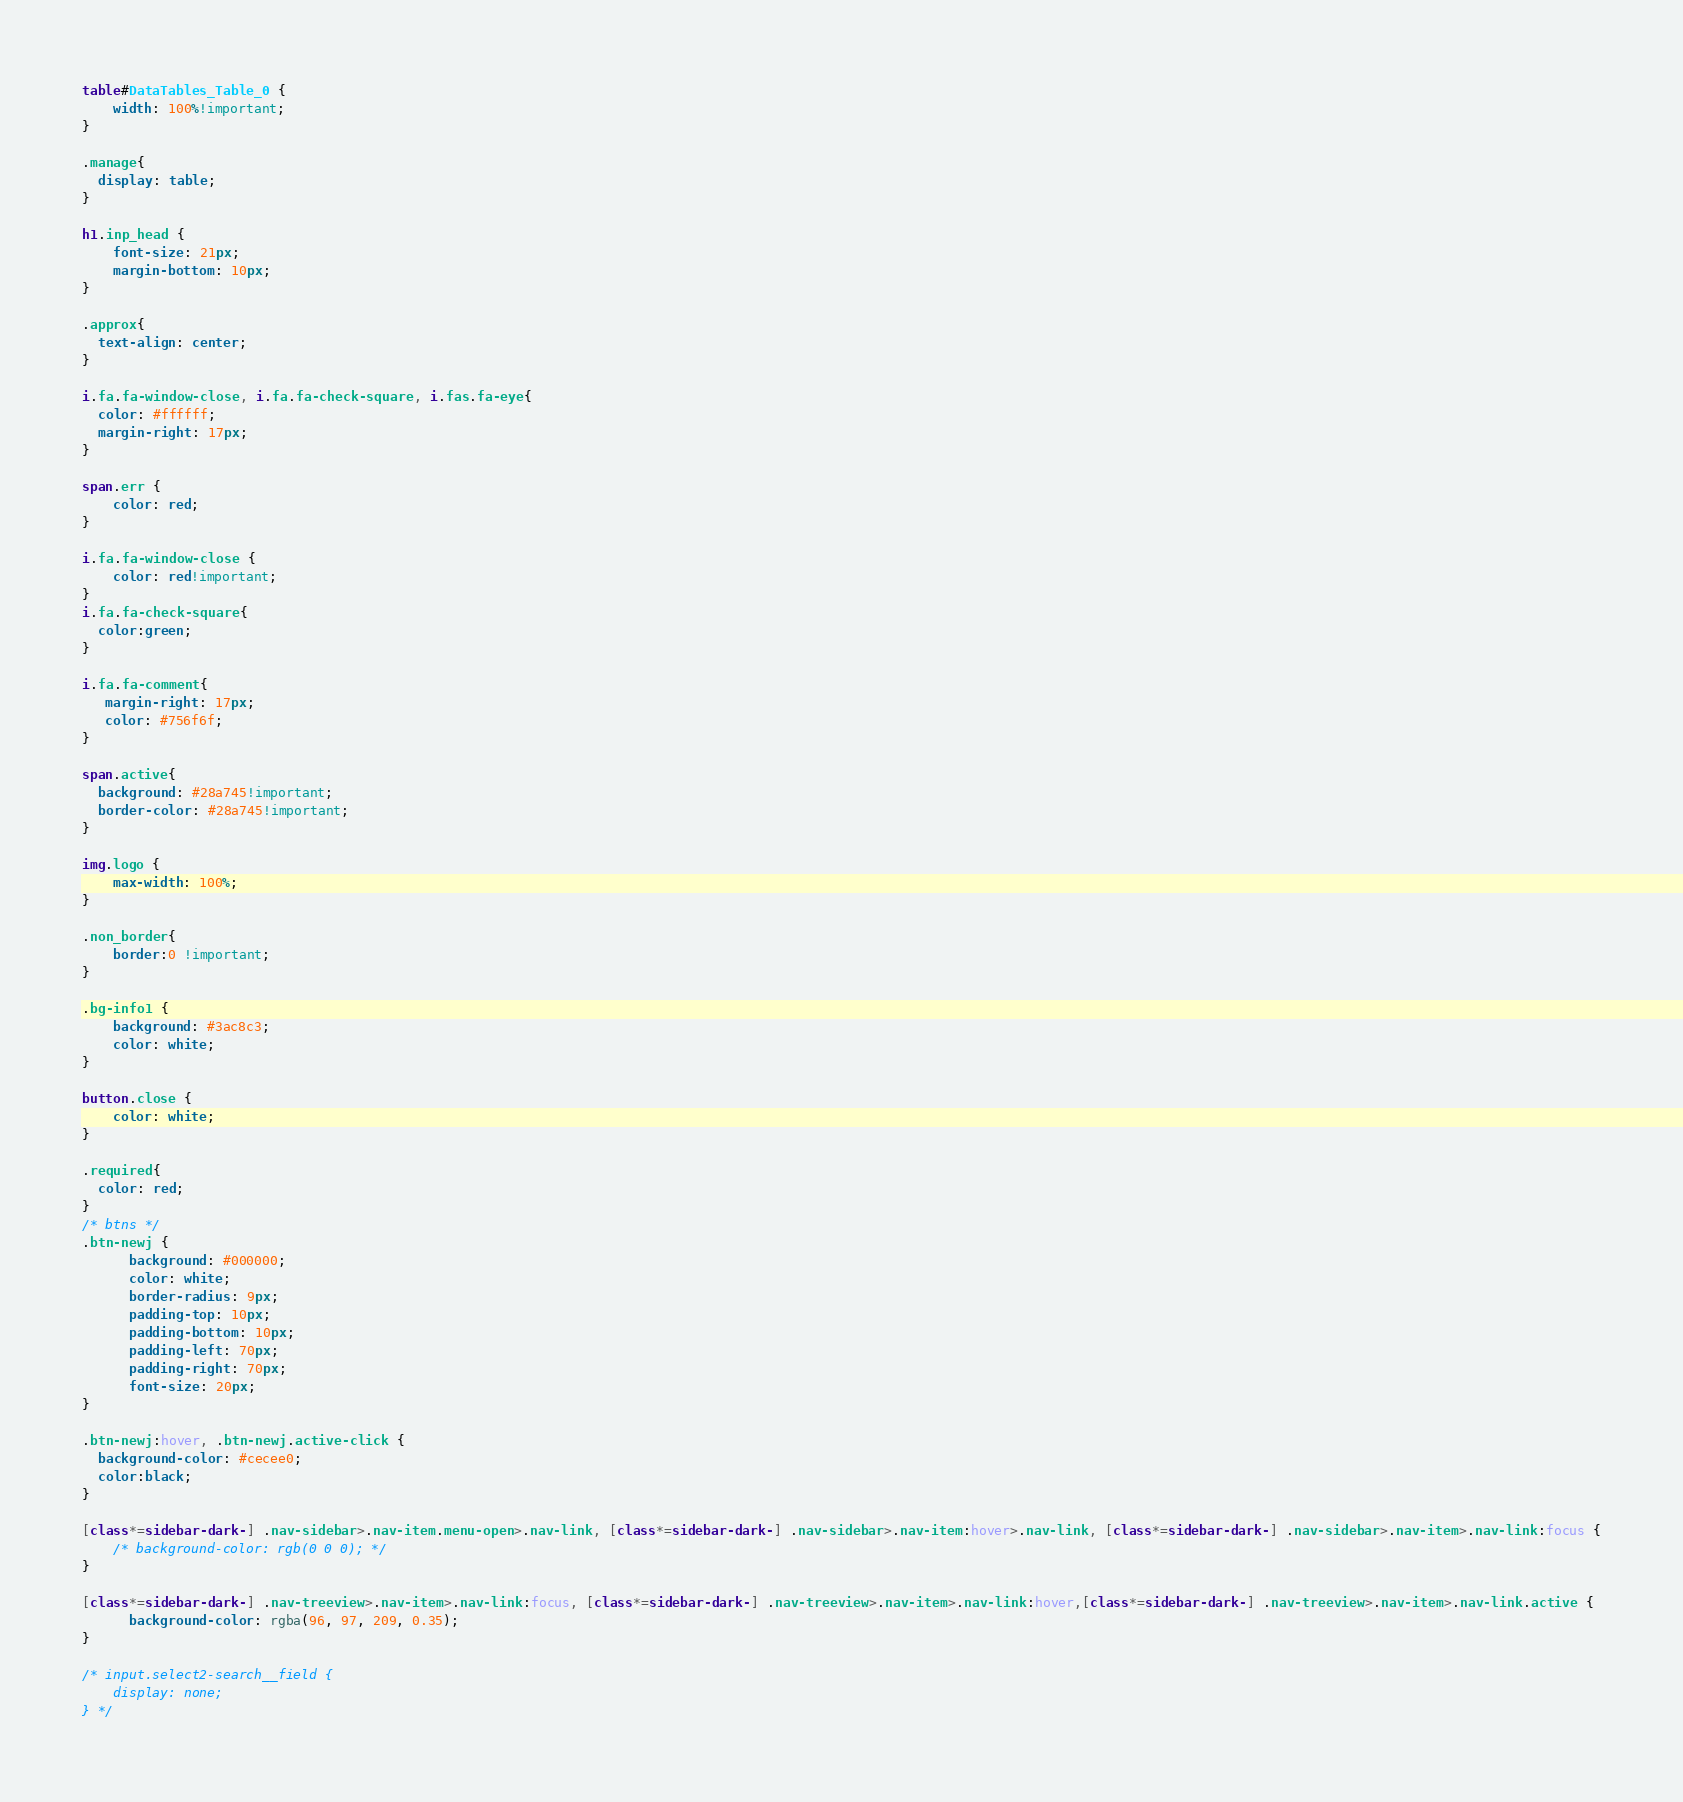<code> <loc_0><loc_0><loc_500><loc_500><_CSS_>table#DataTables_Table_0 {
    width: 100%!important;
}

.manage{
  display: table;
}

h1.inp_head {
    font-size: 21px;
    margin-bottom: 10px;
}

.approx{
  text-align: center;
}

i.fa.fa-window-close, i.fa.fa-check-square, i.fas.fa-eye{
  color: #ffffff;
  margin-right: 17px;
}

span.err {
    color: red;
}

i.fa.fa-window-close {
    color: red!important;
}
i.fa.fa-check-square{
  color:green;
}

i.fa.fa-comment{
   margin-right: 17px;
   color: #756f6f;
}

span.active{
  background: #28a745!important;
  border-color: #28a745!important;
}

img.logo {
    max-width: 100%;
}

.non_border{
    border:0 !important;
}

.bg-info1 {
    background: #3ac8c3;
    color: white;
}

button.close {
    color: white;
}

.required{
  color: red;
}
/* btns */
.btn-newj {
      background: #000000;
      color: white;
      border-radius: 9px;
      padding-top: 10px;
      padding-bottom: 10px;
      padding-left: 70px;
      padding-right: 70px;
      font-size: 20px;
}

.btn-newj:hover, .btn-newj.active-click {
  background-color: #cecee0;
  color:black;
}

[class*=sidebar-dark-] .nav-sidebar>.nav-item.menu-open>.nav-link, [class*=sidebar-dark-] .nav-sidebar>.nav-item:hover>.nav-link, [class*=sidebar-dark-] .nav-sidebar>.nav-item>.nav-link:focus {
    /* background-color: rgb(0 0 0); */
}

[class*=sidebar-dark-] .nav-treeview>.nav-item>.nav-link:focus, [class*=sidebar-dark-] .nav-treeview>.nav-item>.nav-link:hover,[class*=sidebar-dark-] .nav-treeview>.nav-item>.nav-link.active {
      background-color: rgba(96, 97, 209, 0.35);
}

/* input.select2-search__field {
    display: none;
} */
</code> 